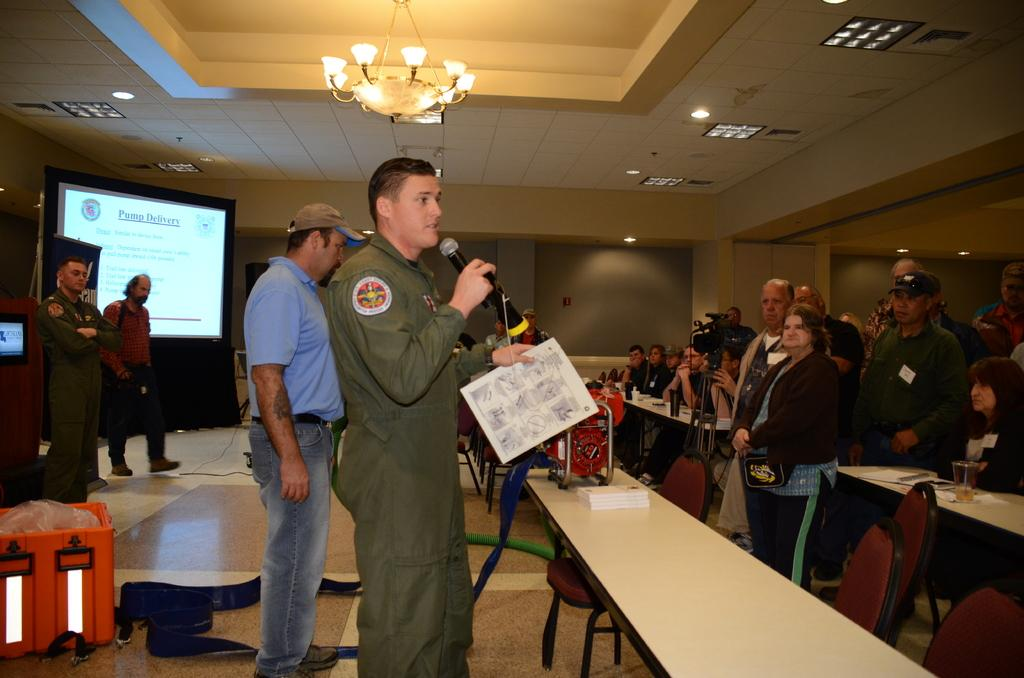What is the man holding in the image? The man is holding a paper and a mic in the image. Can you describe the people in the image? There are people in the image, but their specific number or appearance cannot be determined from the provided facts. What is the purpose of the screen in the image? The purpose of the screen in the image cannot be determined from the provided facts. What is the purpose of the tablet in the image? The purpose of the tablet in the image cannot be determined from the provided facts. What is the purpose of the camera in the image? The purpose of the camera in the image cannot be determined from the provided facts. What is the purpose of the lights in the image? The purpose of the lights in the image cannot be determined from the provided facts. What is on the table in the image? There are papers, a book, and glasses on the table in the image. What type of seating is present in the image? There are chairs in the image. What color is the minister's robe in the image? There is no minister or robe present in the image. What type of boats can be seen in the harbor in the image? There is no harbor or boats present in the image. 